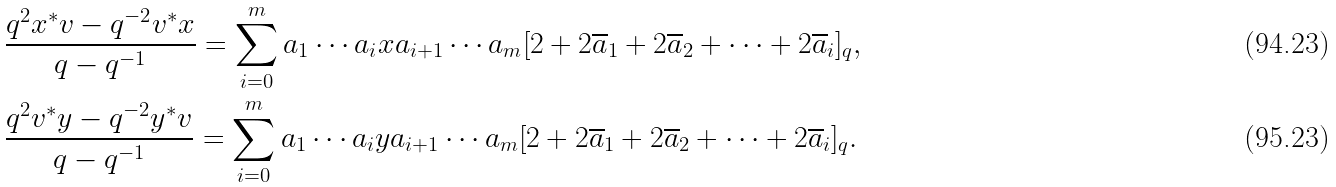Convert formula to latex. <formula><loc_0><loc_0><loc_500><loc_500>& \frac { q ^ { 2 } x ^ { * } v - q ^ { - 2 } v ^ { * } x } { q - q ^ { - 1 } } = \sum _ { i = 0 } ^ { m } a _ { 1 } \cdots a _ { i } x a _ { i + 1 } \cdots a _ { m } [ 2 + 2 \overline { a } _ { 1 } + 2 \overline { a } _ { 2 } + \cdots + 2 \overline { a } _ { i } ] _ { q } , \\ & \frac { q ^ { 2 } v ^ { * } y - q ^ { - 2 } y ^ { * } v } { q - q ^ { - 1 } } = \sum _ { i = 0 } ^ { m } a _ { 1 } \cdots a _ { i } y a _ { i + 1 } \cdots a _ { m } [ 2 + 2 \overline { a } _ { 1 } + 2 \overline { a } _ { 2 } + \cdots + 2 \overline { a } _ { i } ] _ { q } .</formula> 